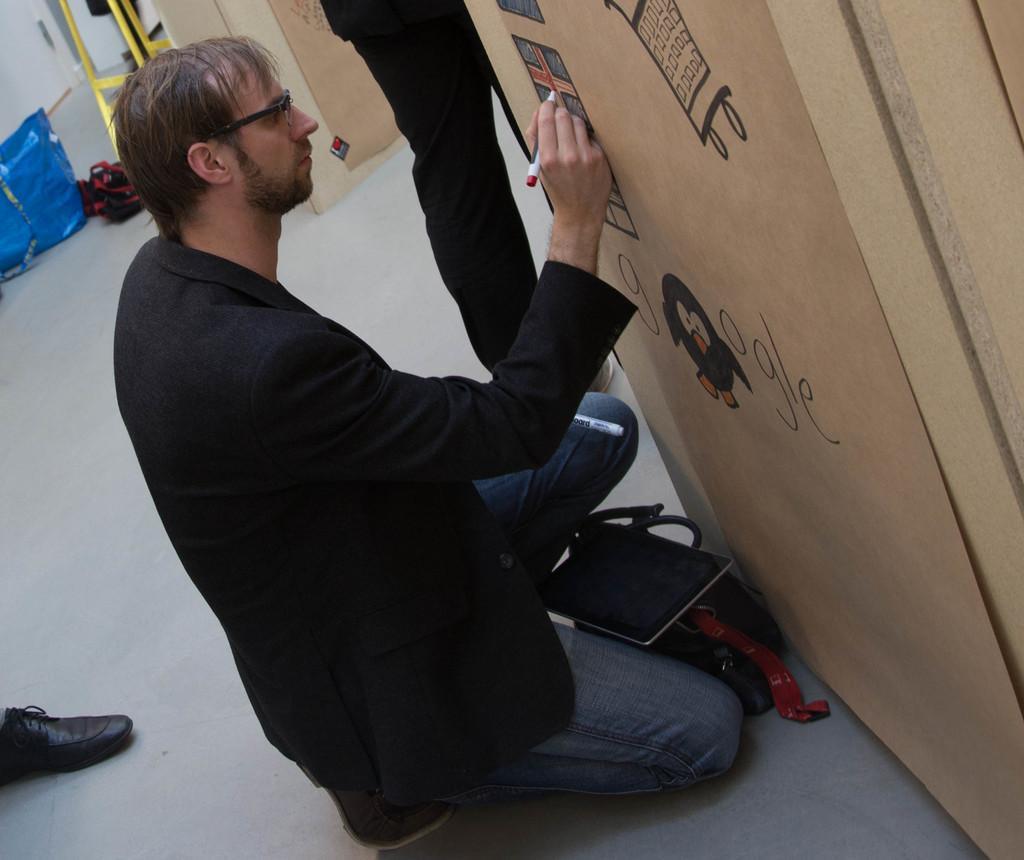In one or two sentences, can you explain what this image depicts? In this picture I can observe a person on the floor. He is wearing a coat and spectacles. The person is drawing on the brown color cardboard sheet. I can observe another person standing in the middle of the picture. In the background I can observe blue color bag on the floor. 